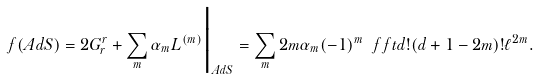<formula> <loc_0><loc_0><loc_500><loc_500>f ( A d S ) = 2 G _ { r } ^ { r } + \sum _ { m } \alpha _ { m } L ^ { ( m ) } \Big | _ { A d S } = \sum _ { m } 2 m \alpha _ { m } ( - 1 ) ^ { m } \ f f t { d ! } { ( d + 1 - 2 m ) ! \ell ^ { 2 m } } .</formula> 